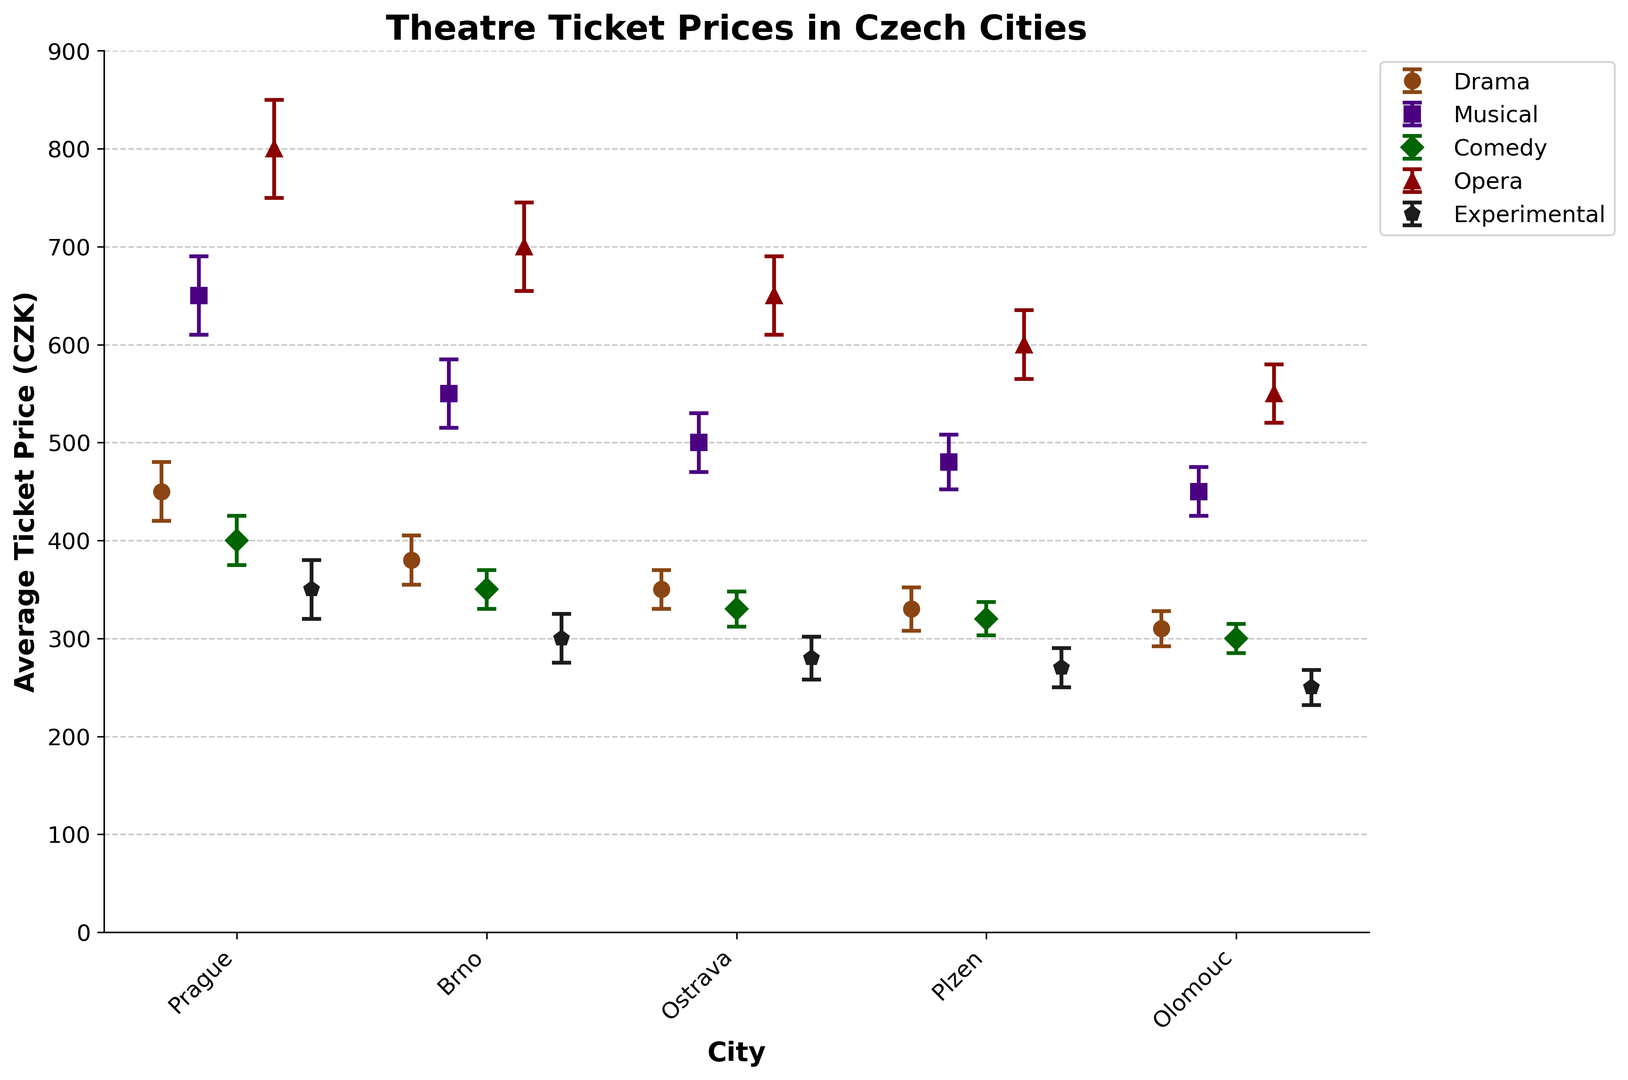What is the average ticket price for Opera in Brno? Locate the Opera genre data and find the value for Brno. The average ticket price in Brno for Opera is shown as 700 CZK.
Answer: 700 CZK Which city has the highest ticket price for Musicals? Look for the maximum value within the Musical genre across all cities. The highest average ticket price for Musicals is in Prague with a value of 650 CZK.
Answer: Prague What is the difference in average price between the most expensive and least expensive Drama tickets? Find the maximum and minimum values in the Drama genre. The most expensive ticket price is in Prague (450 CZK) and the least expensive in Olomouc (310 CZK). Calculating the difference gives 450 - 310 = 140 CZK.
Answer: 140 CZK Which genre has the lowest uncertainty for ticket prices in Plzen? Compare the uncertainties across all genres in Plzen. The lowest uncertainty value is for Comedy with 17 CZK.
Answer: Comedy What is the sum of average ticket prices for Experimental theatre across all cities? Add up the average ticket prices for Experimental theatre in all cities: 350 + 300 + 280 + 270 + 250 = 1450 CZK.
Answer: 1450 CZK Which genre shows the greatest variation in ticket prices across different cities? Determine the range (difference between max and min values) for each genre across all cities. Opera has the highest range with max 800 CZK (Prague) and min 550 CZK (Olomouc), giving a range of 250 CZK.
Answer: Opera Between Musical and Comedy, which genre has generally higher ticket prices in Ostrava? Compare the average ticket prices for Musical and Comedy in Ostrava. Musical prices are higher (500 CZK) compared to Comedy (330 CZK).
Answer: Musical How much greater is the average ticket price for Drama in Prague compared to Olomouc? Locate the average prices for Drama in Prague (450 CZK) and Olomouc (310 CZK). Subtract the two values: 450 - 310 = 140 CZK.
Answer: 140 CZK Are ticket prices for Experimental theatre generally cheaper or more expensive than ticket prices for Comedy in Plzen? Compare the average ticket prices for Experimental (270 CZK) and Comedy (320 CZK) in Plzen. Experimental theatre is cheaper.
Answer: Cheaper 